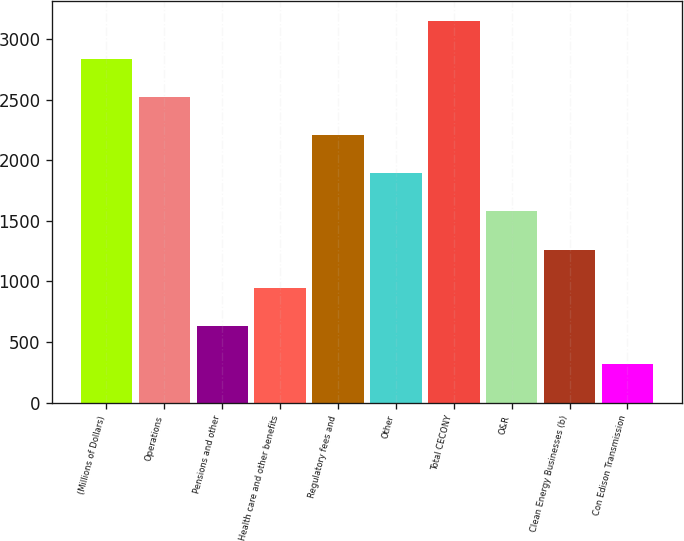Convert chart to OTSL. <chart><loc_0><loc_0><loc_500><loc_500><bar_chart><fcel>(Millions of Dollars)<fcel>Operations<fcel>Pensions and other<fcel>Health care and other benefits<fcel>Regulatory fees and<fcel>Other<fcel>Total CECONY<fcel>O&R<fcel>Clean Energy Businesses (b)<fcel>Con Edison Transmission<nl><fcel>2837.3<fcel>2522.6<fcel>634.4<fcel>949.1<fcel>2207.9<fcel>1893.2<fcel>3152<fcel>1578.5<fcel>1263.8<fcel>319.7<nl></chart> 